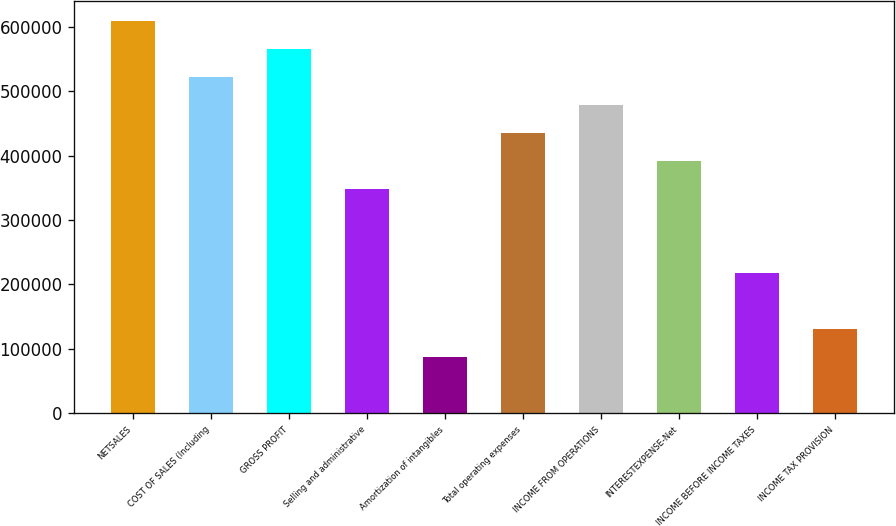<chart> <loc_0><loc_0><loc_500><loc_500><bar_chart><fcel>NETSALES<fcel>COST OF SALES (Including<fcel>GROSS PROFIT<fcel>Selling and administrative<fcel>Amortization of intangibles<fcel>Total operating expenses<fcel>INCOME FROM OPERATIONS<fcel>INTERESTEXPENSE-Net<fcel>INCOME BEFORE INCOME TAXES<fcel>INCOME TAX PROVISION<nl><fcel>609229<fcel>522197<fcel>565713<fcel>348131<fcel>87033.2<fcel>435164<fcel>478680<fcel>391648<fcel>217582<fcel>130550<nl></chart> 